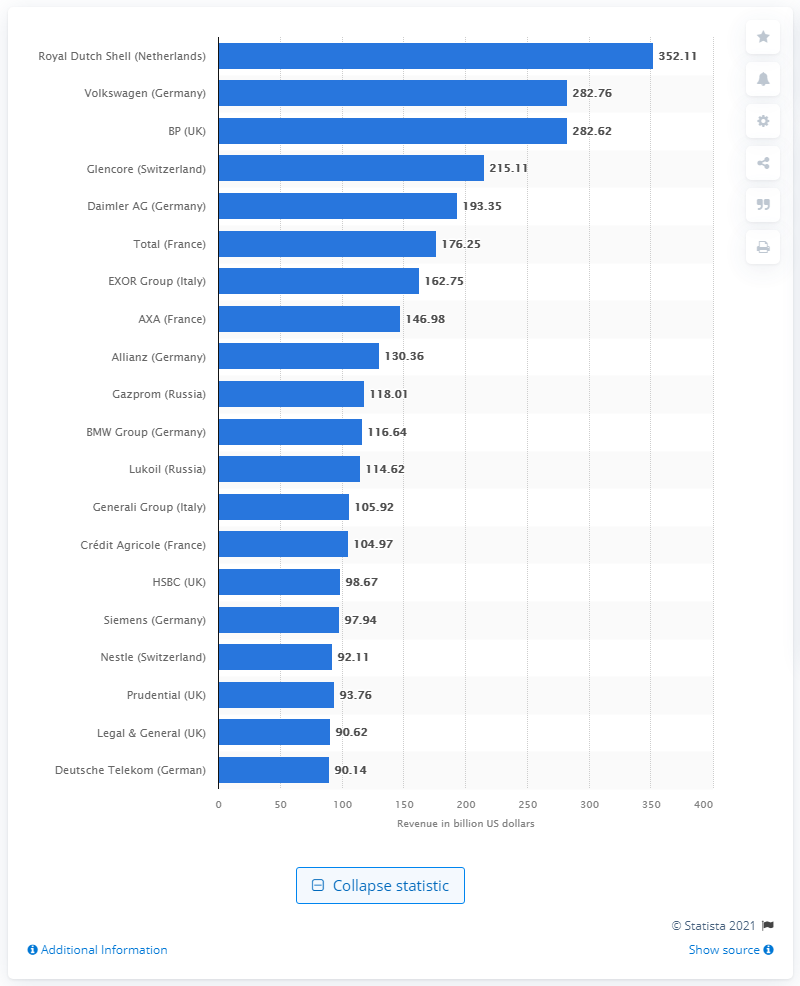Specify some key components in this picture. In 2020, the revenue of Royal Dutch Shell was 352.11. 